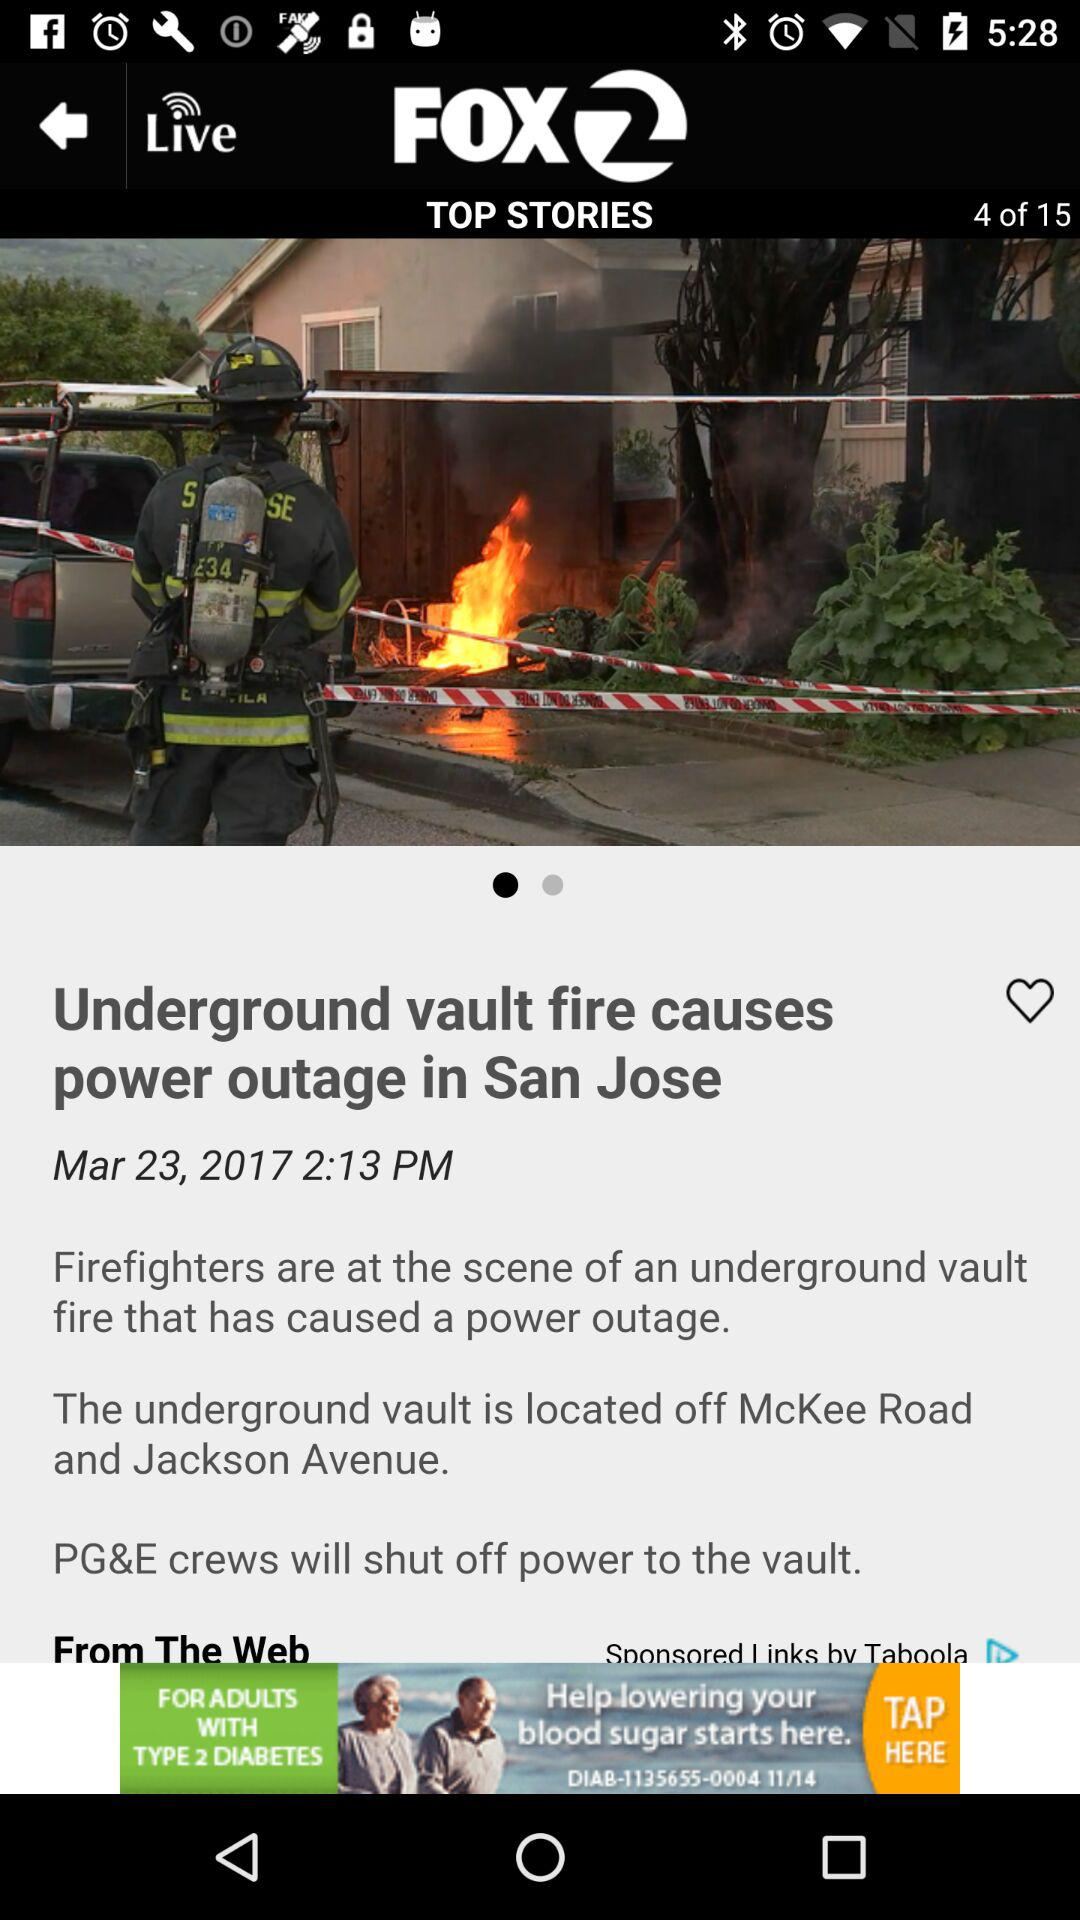At what story am I on? You are on story no. 4. 